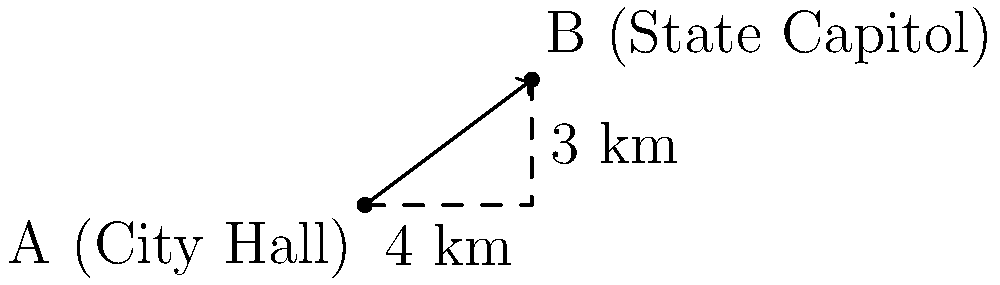As part of a Freedom of Information Act (FOIA) request, you need to calculate the straight-line distance between City Hall and the State Capitol. Given that City Hall is at point A(0,0) and the State Capitol is at point B(4,3) on a coordinate grid where each unit represents 1 km, what is the magnitude of the vector $\overrightarrow{AB}$ representing the distance between these two government buildings? To calculate the magnitude of vector $\overrightarrow{AB}$, we can use the Pythagorean theorem, as the vector forms the hypotenuse of a right triangle.

Step 1: Identify the components of the vector.
The horizontal component (x) is 4 km.
The vertical component (y) is 3 km.

Step 2: Apply the Pythagorean theorem.
The magnitude of the vector is given by:
$|\overrightarrow{AB}| = \sqrt{x^2 + y^2}$

Step 3: Substitute the values.
$|\overrightarrow{AB}| = \sqrt{4^2 + 3^2}$

Step 4: Calculate.
$|\overrightarrow{AB}| = \sqrt{16 + 9} = \sqrt{25} = 5$

Therefore, the magnitude of vector $\overrightarrow{AB}$, representing the straight-line distance between City Hall and the State Capitol, is 5 km.
Answer: 5 km 